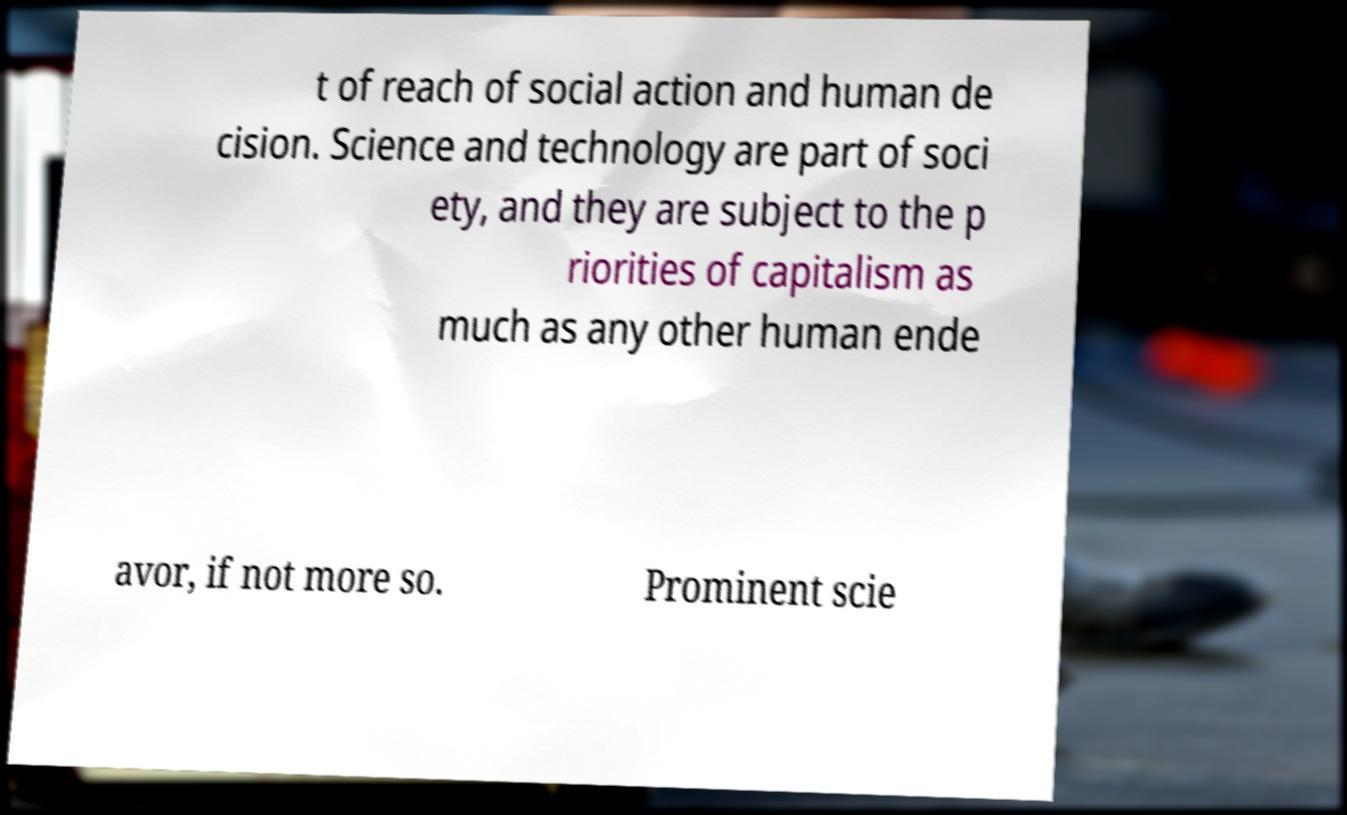Could you assist in decoding the text presented in this image and type it out clearly? t of reach of social action and human de cision. Science and technology are part of soci ety, and they are subject to the p riorities of capitalism as much as any other human ende avor, if not more so. Prominent scie 